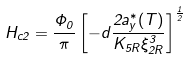<formula> <loc_0><loc_0><loc_500><loc_500>H _ { c 2 } = \frac { \Phi _ { 0 } } { \pi } \left [ - d \frac { 2 a ^ { * } _ { y } ( T ) } { K _ { 5 R } \xi _ { 2 R } ^ { 3 } } \right ] ^ { \frac { 1 } { 2 } }</formula> 